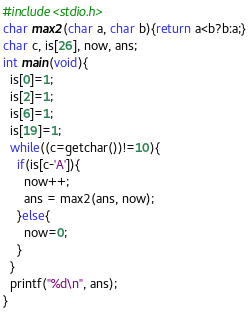Convert code to text. <code><loc_0><loc_0><loc_500><loc_500><_C_>#include<stdio.h>
char max2(char a, char b){return a<b?b:a;}
char c, is[26], now, ans;
int main(void){
  is[0]=1;
  is[2]=1;
  is[6]=1;
  is[19]=1;
  while((c=getchar())!=10){
    if(is[c-'A']){
      now++;
      ans = max2(ans, now);
    }else{
      now=0;
    }
  }
  printf("%d\n", ans);
}
</code> 